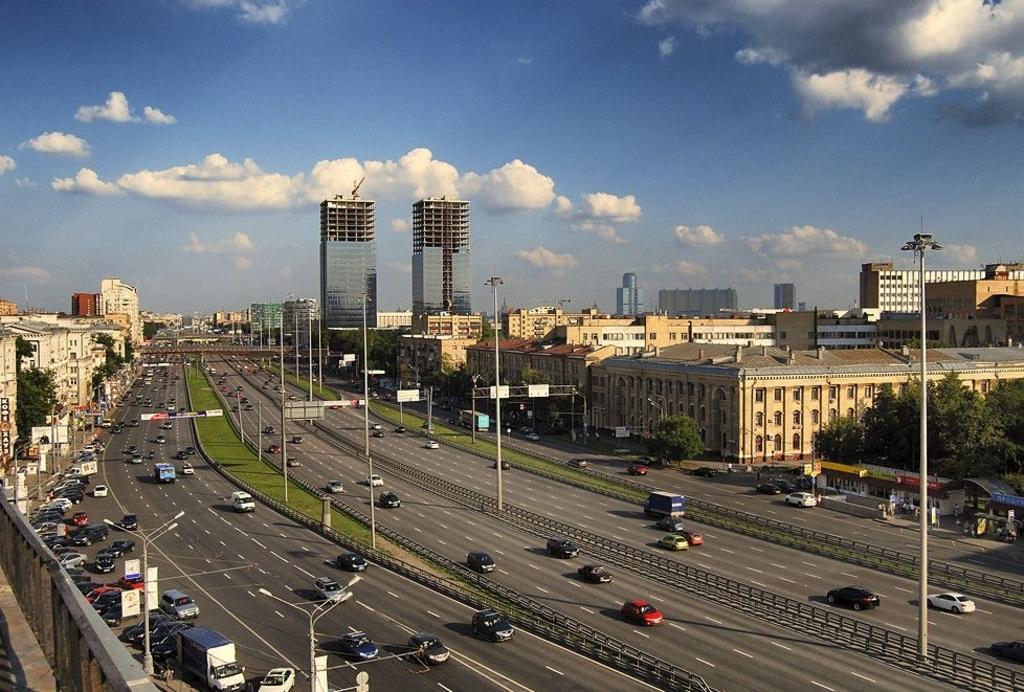Could you give a brief overview of what you see in this image? This is the top view of an image where we can see many vehicles are moving on the road. On the left side of the image we can see vehicles parked on the side of the road, we can see light poles, buildings on the either side of the image, we can see trees and the blue color sky with clouds in the background. 